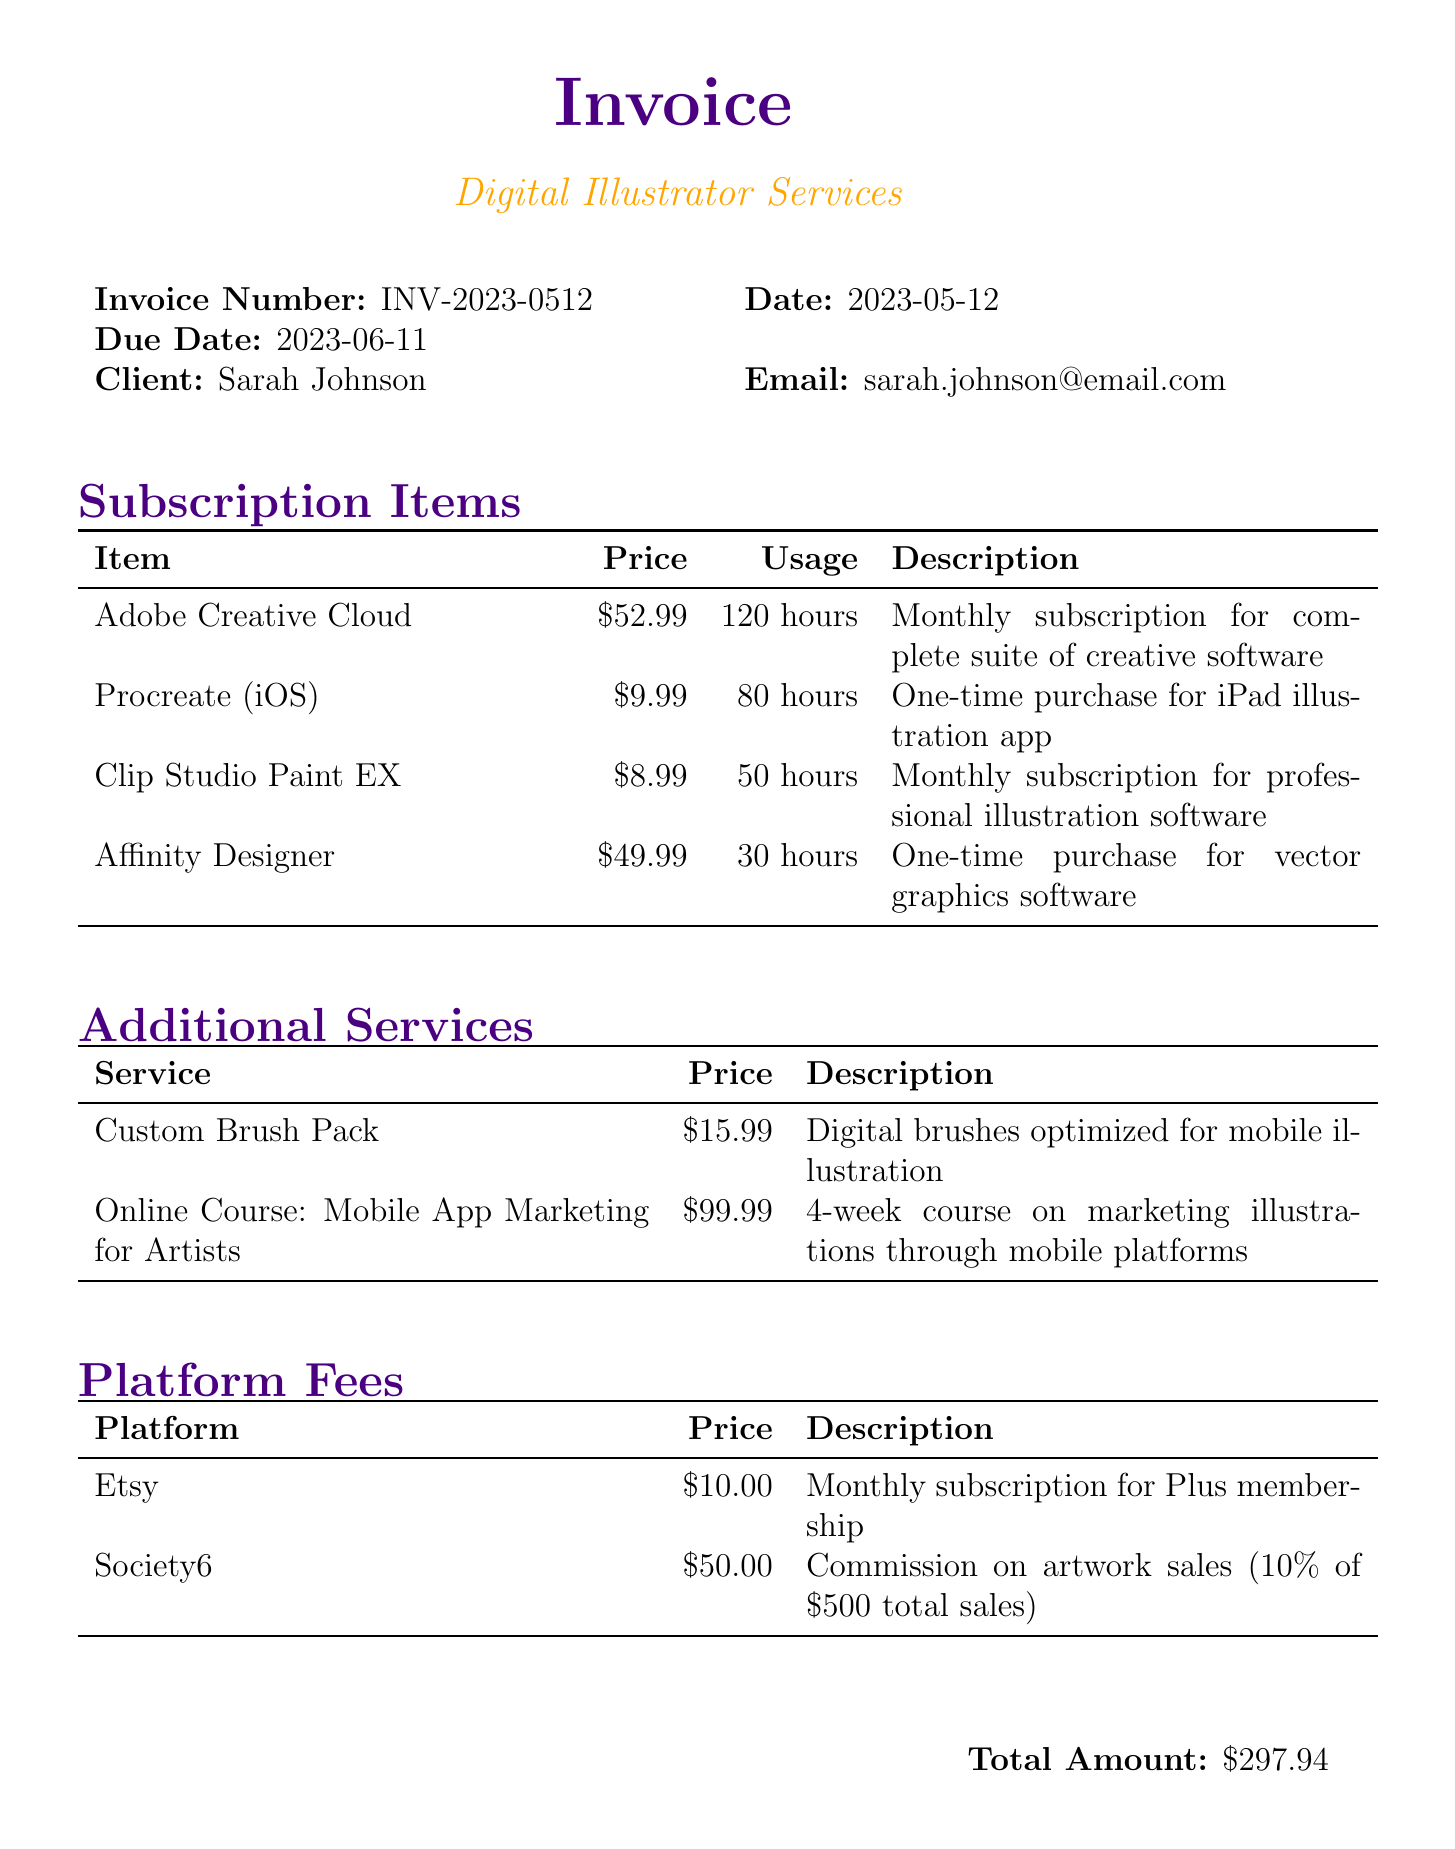What is the invoice number? The invoice number is listed at the top of the document under invoice details.
Answer: INV-2023-0512 What is the due date of the invoice? The due date is specified in the invoice details section.
Answer: 2023-06-11 How many hours was Adobe Creative Cloud used this month? The usage statistics for Adobe Creative Cloud are mentioned in the subscription items section.
Answer: 120 hours What is the price of the Online Course: Mobile App Marketing for Artists? The price is provided in the additional services section of the invoice.
Answer: $99.99 What is the total amount due for this invoice? The total amount is indicated at the bottom of the invoice.
Answer: $297.94 How many different subscription items are listed? The subscription items section contains the number of items listed.
Answer: 4 What payment methods are accepted according to the invoice? The payment methods are outlined in the payment information section.
Answer: PayPal, Credit Card, Bank Transfer What additional service is priced at $15.99? The additional services section mentions this service along with its price.
Answer: Custom Brush Pack What platform has a monthly subscription fee of $10.00? The platform fees section provides the name of the platform with this fee.
Answer: Etsy 